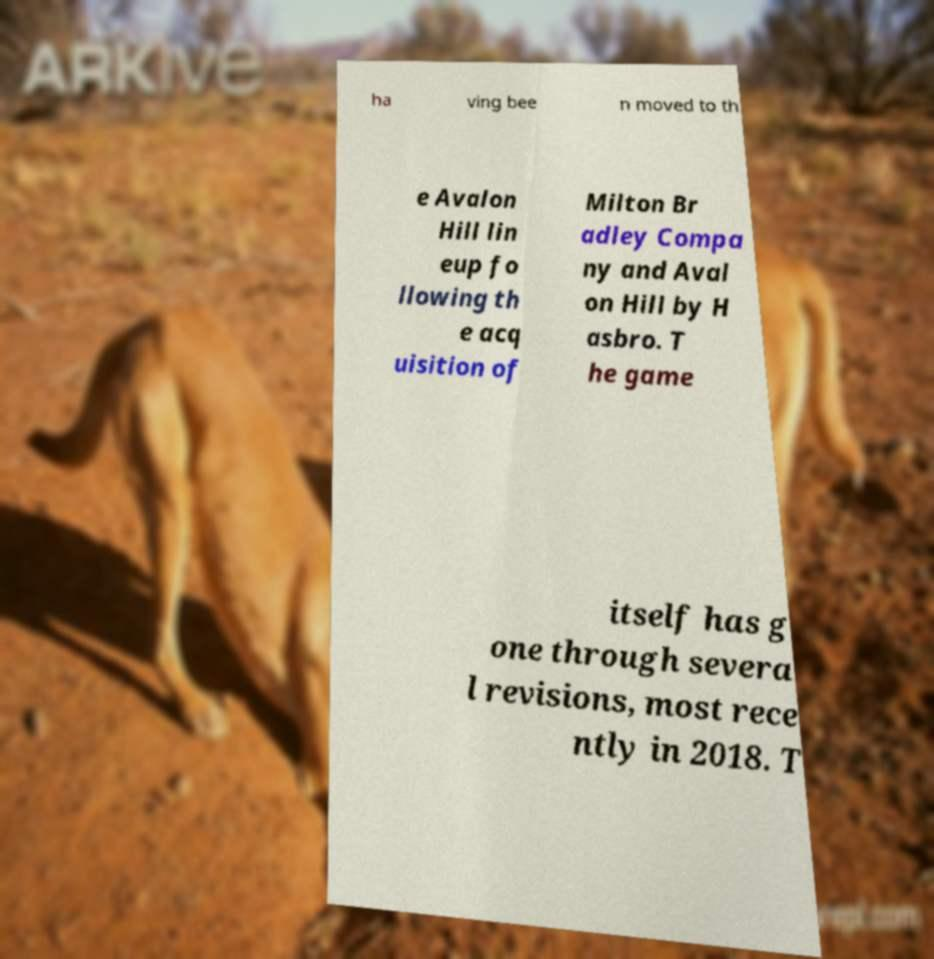Can you accurately transcribe the text from the provided image for me? ha ving bee n moved to th e Avalon Hill lin eup fo llowing th e acq uisition of Milton Br adley Compa ny and Aval on Hill by H asbro. T he game itself has g one through severa l revisions, most rece ntly in 2018. T 